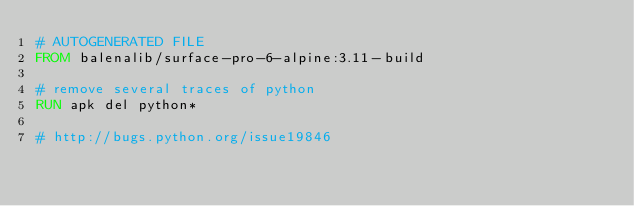<code> <loc_0><loc_0><loc_500><loc_500><_Dockerfile_># AUTOGENERATED FILE
FROM balenalib/surface-pro-6-alpine:3.11-build

# remove several traces of python
RUN apk del python*

# http://bugs.python.org/issue19846</code> 